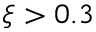<formula> <loc_0><loc_0><loc_500><loc_500>\xi > 0 . 3</formula> 